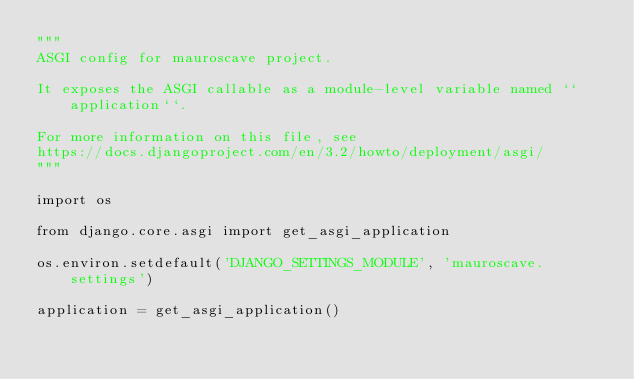Convert code to text. <code><loc_0><loc_0><loc_500><loc_500><_Python_>"""
ASGI config for mauroscave project.

It exposes the ASGI callable as a module-level variable named ``application``.

For more information on this file, see
https://docs.djangoproject.com/en/3.2/howto/deployment/asgi/
"""

import os

from django.core.asgi import get_asgi_application

os.environ.setdefault('DJANGO_SETTINGS_MODULE', 'mauroscave.settings')

application = get_asgi_application()
</code> 